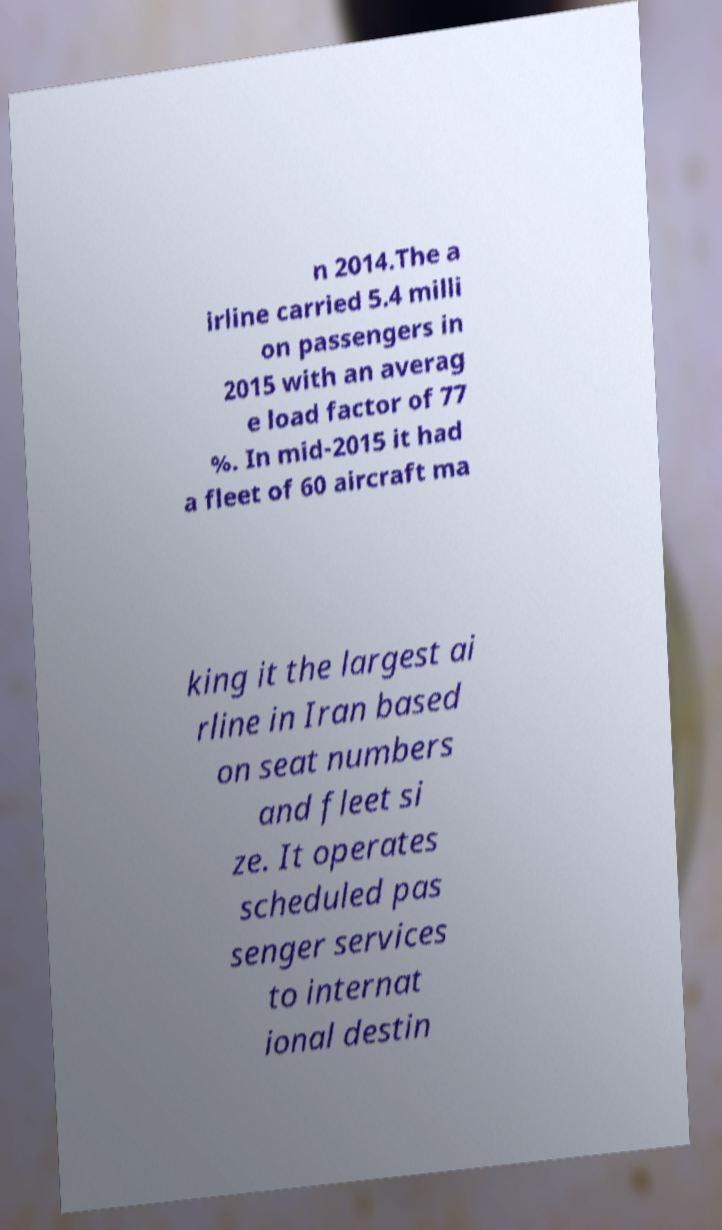Could you extract and type out the text from this image? n 2014.The a irline carried 5.4 milli on passengers in 2015 with an averag e load factor of 77 %. In mid-2015 it had a fleet of 60 aircraft ma king it the largest ai rline in Iran based on seat numbers and fleet si ze. It operates scheduled pas senger services to internat ional destin 